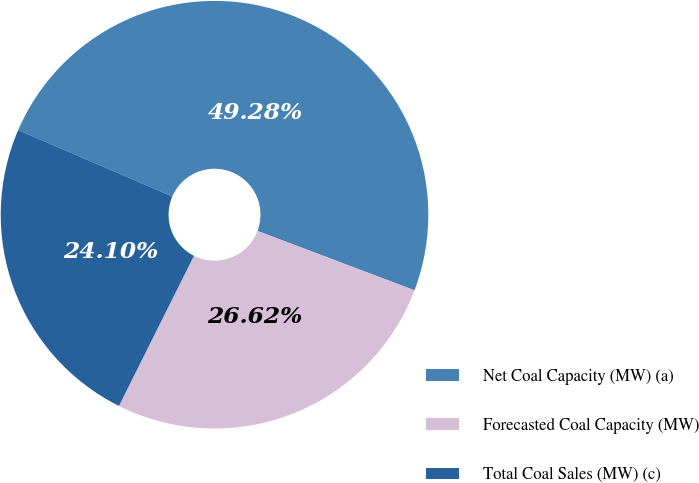Convert chart. <chart><loc_0><loc_0><loc_500><loc_500><pie_chart><fcel>Net Coal Capacity (MW) (a)<fcel>Forecasted Coal Capacity (MW)<fcel>Total Coal Sales (MW) (c)<nl><fcel>49.28%<fcel>26.62%<fcel>24.1%<nl></chart> 